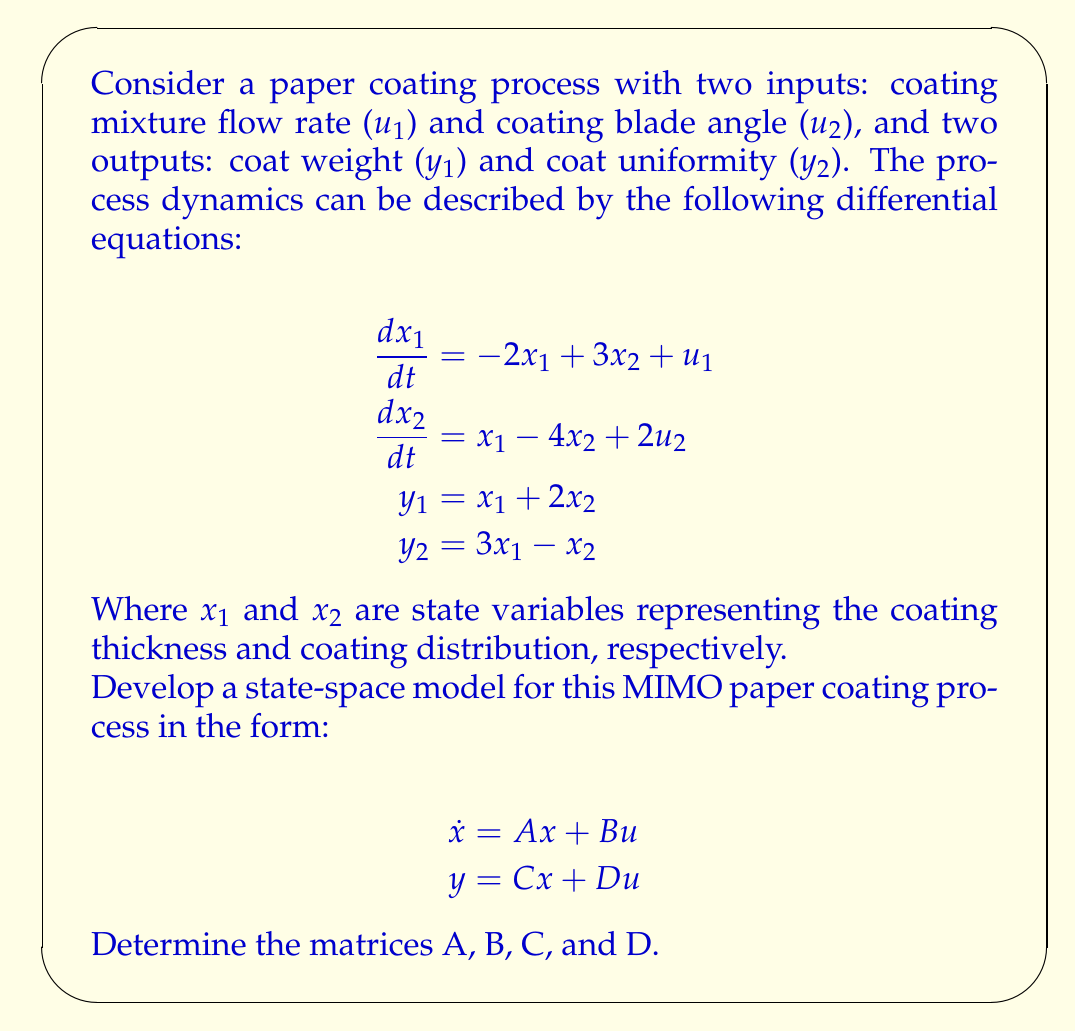Can you answer this question? To develop the state-space model, we need to identify the components of the general state-space form:

$$\dot{x} = Ax + Bu$$
$$y = Cx + Du$$

Where:
- $x$ is the state vector
- $u$ is the input vector
- $y$ is the output vector
- $A$ is the system matrix
- $B$ is the input matrix
- $C$ is the output matrix
- $D$ is the feedthrough matrix

Step 1: Identify the state vector, input vector, and output vector.
State vector: $x = \begin{bmatrix} x_1 \\ x_2 \end{bmatrix}$
Input vector: $u = \begin{bmatrix} u_1 \\ u_2 \end{bmatrix}$
Output vector: $y = \begin{bmatrix} y_1 \\ y_2 \end{bmatrix}$

Step 2: Determine the A matrix from the state equations.
$$\frac{dx_1}{dt} = -2x_1 + 3x_2 + u_1$$
$$\frac{dx_2}{dt} = x_1 - 4x_2 + 2u_2$$

The A matrix is:
$$A = \begin{bmatrix} -2 & 3 \\ 1 & -4 \end{bmatrix}$$

Step 3: Determine the B matrix from the input terms in the state equations.
$$B = \begin{bmatrix} 1 & 0 \\ 0 & 2 \end{bmatrix}$$

Step 4: Determine the C matrix from the output equations.
$$y_1 = x_1 + 2x_2$$
$$y_2 = 3x_1 - x_2$$

The C matrix is:
$$C = \begin{bmatrix} 1 & 2 \\ 3 & -1 \end{bmatrix}$$

Step 5: Determine the D matrix. Since there are no direct feedthrough terms from the inputs to the outputs, the D matrix is a zero matrix.
$$D = \begin{bmatrix} 0 & 0 \\ 0 & 0 \end{bmatrix}$$

Now we have all the components of the state-space model.
Answer: The state-space model for the MIMO paper coating process is:

$$\dot{x} = \begin{bmatrix} -2 & 3 \\ 1 & -4 \end{bmatrix}x + \begin{bmatrix} 1 & 0 \\ 0 & 2 \end{bmatrix}u$$
$$y = \begin{bmatrix} 1 & 2 \\ 3 & -1 \end{bmatrix}x + \begin{bmatrix} 0 & 0 \\ 0 & 0 \end{bmatrix}u$$

Where:
$A = \begin{bmatrix} -2 & 3 \\ 1 & -4 \end{bmatrix}$
$B = \begin{bmatrix} 1 & 0 \\ 0 & 2 \end{bmatrix}$
$C = \begin{bmatrix} 1 & 2 \\ 3 & -1 \end{bmatrix}$
$D = \begin{bmatrix} 0 & 0 \\ 0 & 0 \end{bmatrix}$ 